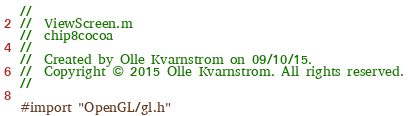Convert code to text. <code><loc_0><loc_0><loc_500><loc_500><_ObjectiveC_>//
//  ViewScreen.m
//  chip8cocoa
//
//  Created by Olle Kvarnstrom on 09/10/15.
//  Copyright © 2015 Olle Kvarnstrom. All rights reserved.
//

#import "OpenGL/gl.h"
</code> 